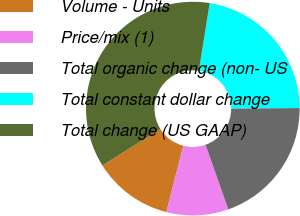Convert chart. <chart><loc_0><loc_0><loc_500><loc_500><pie_chart><fcel>Volume - Units<fcel>Price/mix (1)<fcel>Total organic change (non- US<fcel>Total constant dollar change<fcel>Total change (US GAAP)<nl><fcel>12.08%<fcel>9.37%<fcel>19.7%<fcel>22.4%<fcel>36.45%<nl></chart> 